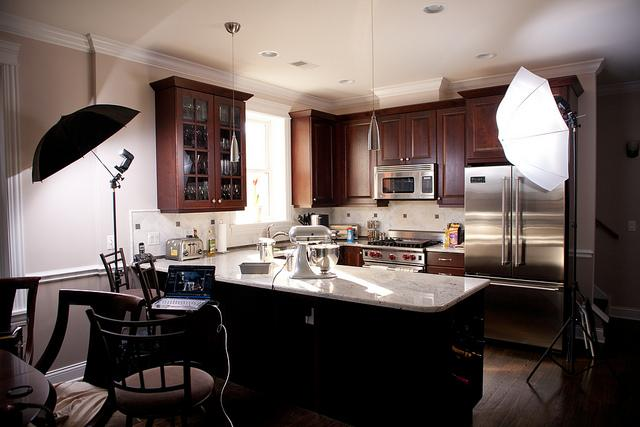What are the umbrellas being used for? lighting 